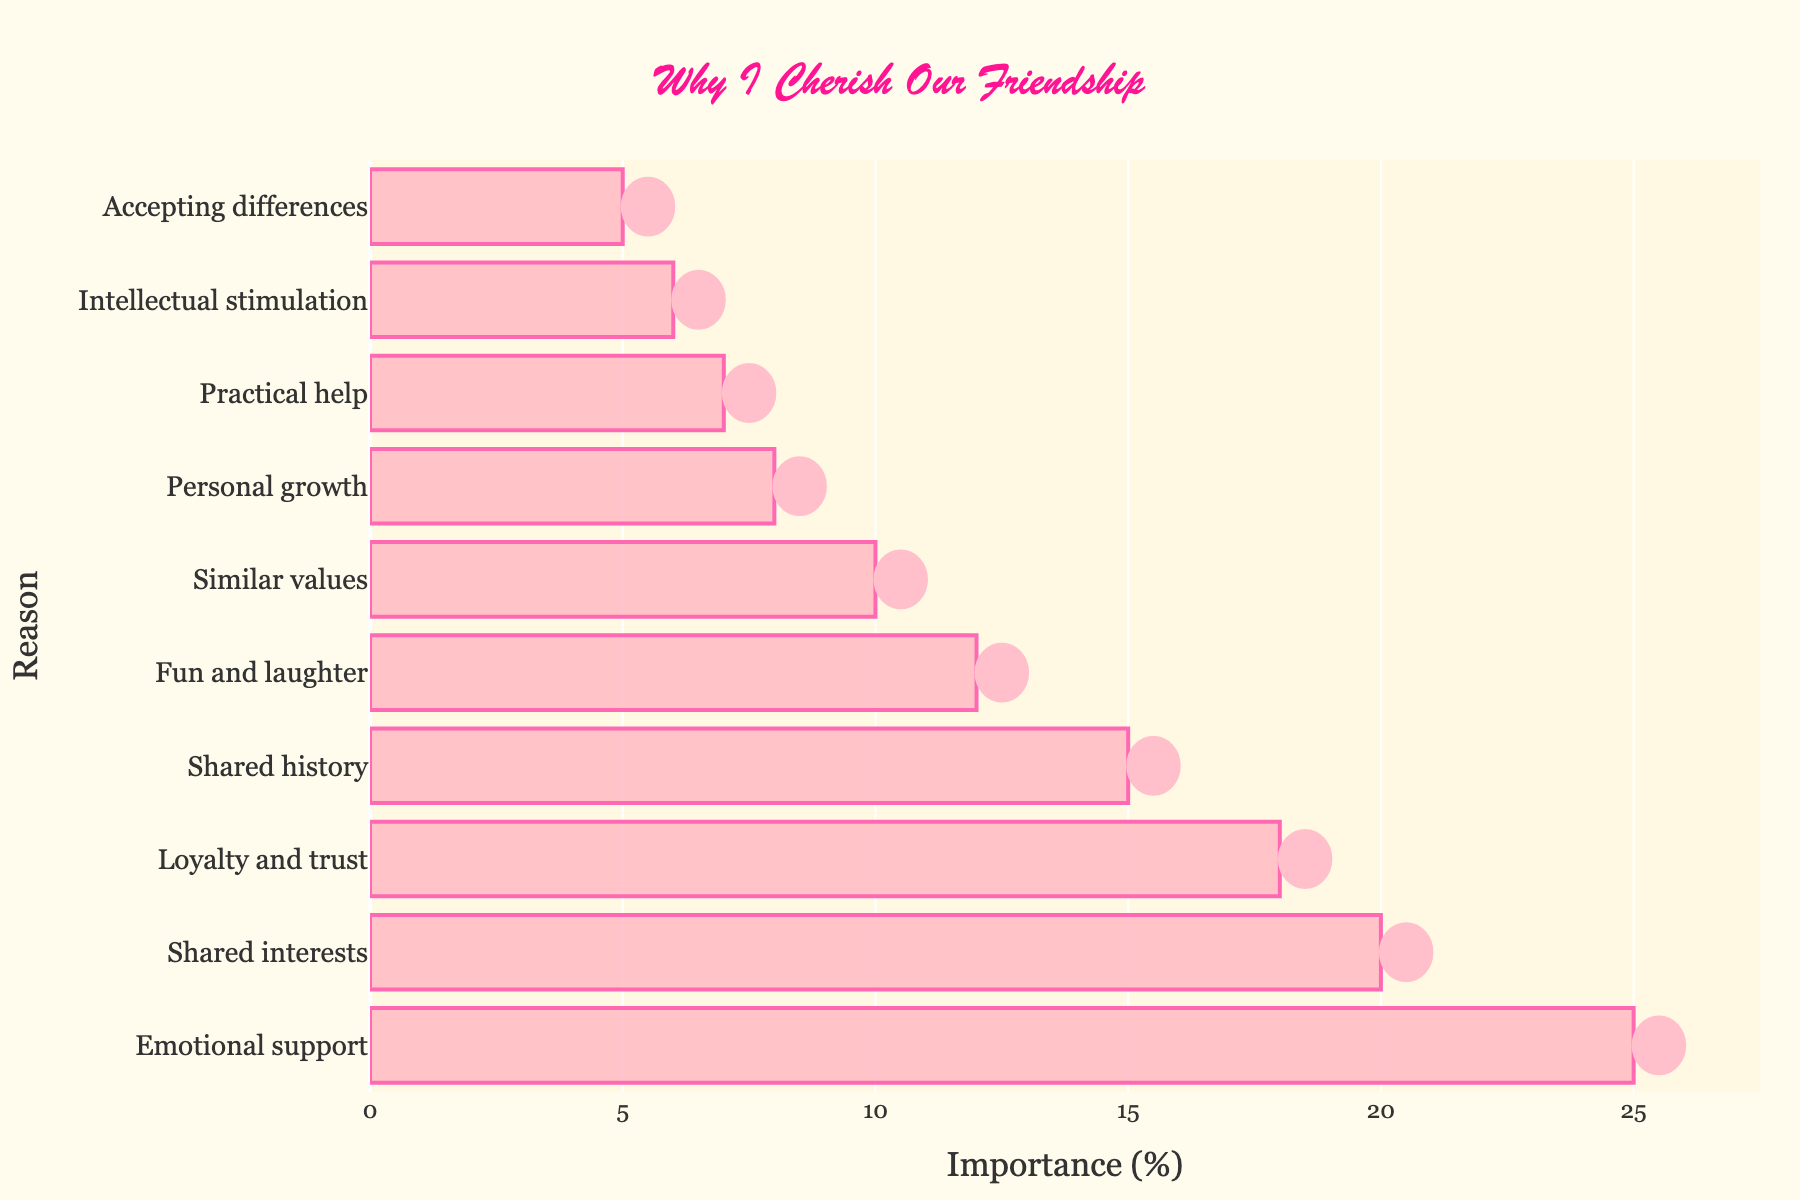What is the most common reason for maintaining long-term friendships according to the chart? The chart shows the percentage of people citing different reasons. The bar with the highest percentage represents the most common reason. "Emotional support" has the highest percentage at 25%.
Answer: Emotional support Which reason is cited more frequently: shared interests or shared history? By comparing the lengths of the bars for "Shared interests" and "Shared history," we can see that "Shared interests" is longer with a percentage of 20%, while "Shared history" is shorter with 15%.
Answer: Shared interests What is the total percentage for the top three reasons for maintaining long-term friendships? The top three reasons are "Emotional support" (25%), "Shared interests" (20%), and "Loyalty and trust" (18%). Summing these percentages: 25 + 20 + 18 = 63%.
Answer: 63% Between "Fun and laughter" and "Similar values," which reason contributes more to maintaining long-term friendships and by how much? The bar for "Fun and laughter" is at 12%, while "Similar values" is at 10%. The difference is 12% - 10% = 2%.
Answer: Fun and laughter by 2% What percentage of people value "Personal growth" as a reason for maintaining long-term friendships? The chart shows "Personal growth" with a percentage adjacent to its bar, which is 8%.
Answer: 8% How many reasons have a percentage that is less than or equal to 10%? The bars for "Similar values" (10%), "Personal growth" (8%), "Practical help" (7%), "Intellectual stimulation" (6%), and "Accepting differences" (5%) all show percentages of 10% or less.
Answer: 5 Which reason ranks fifth in the list and what is its percentage? Counting from the top, the fifth bar represents "Fun and laughter," which has a percentage of 12%.
Answer: Fun and laughter, 12% Compare the combined percentage of "Practical help" and "Intellectual stimulation" to "Shared history." Which is greater, and by how much? "Practical help" is 7% and "Intellectual stimulation" is 6%, so combined they are 7 + 6 = 13%. "Shared history" is 15%. The difference is 15% - 13% = 2%, with "Shared history" being greater.
Answer: Shared history by 2% Which reason is the least common for maintaining long-term friendships? The shortest bar in the chart, representing the smallest percentage, is for "Accepting differences" at 5%.
Answer: Accepting differences 